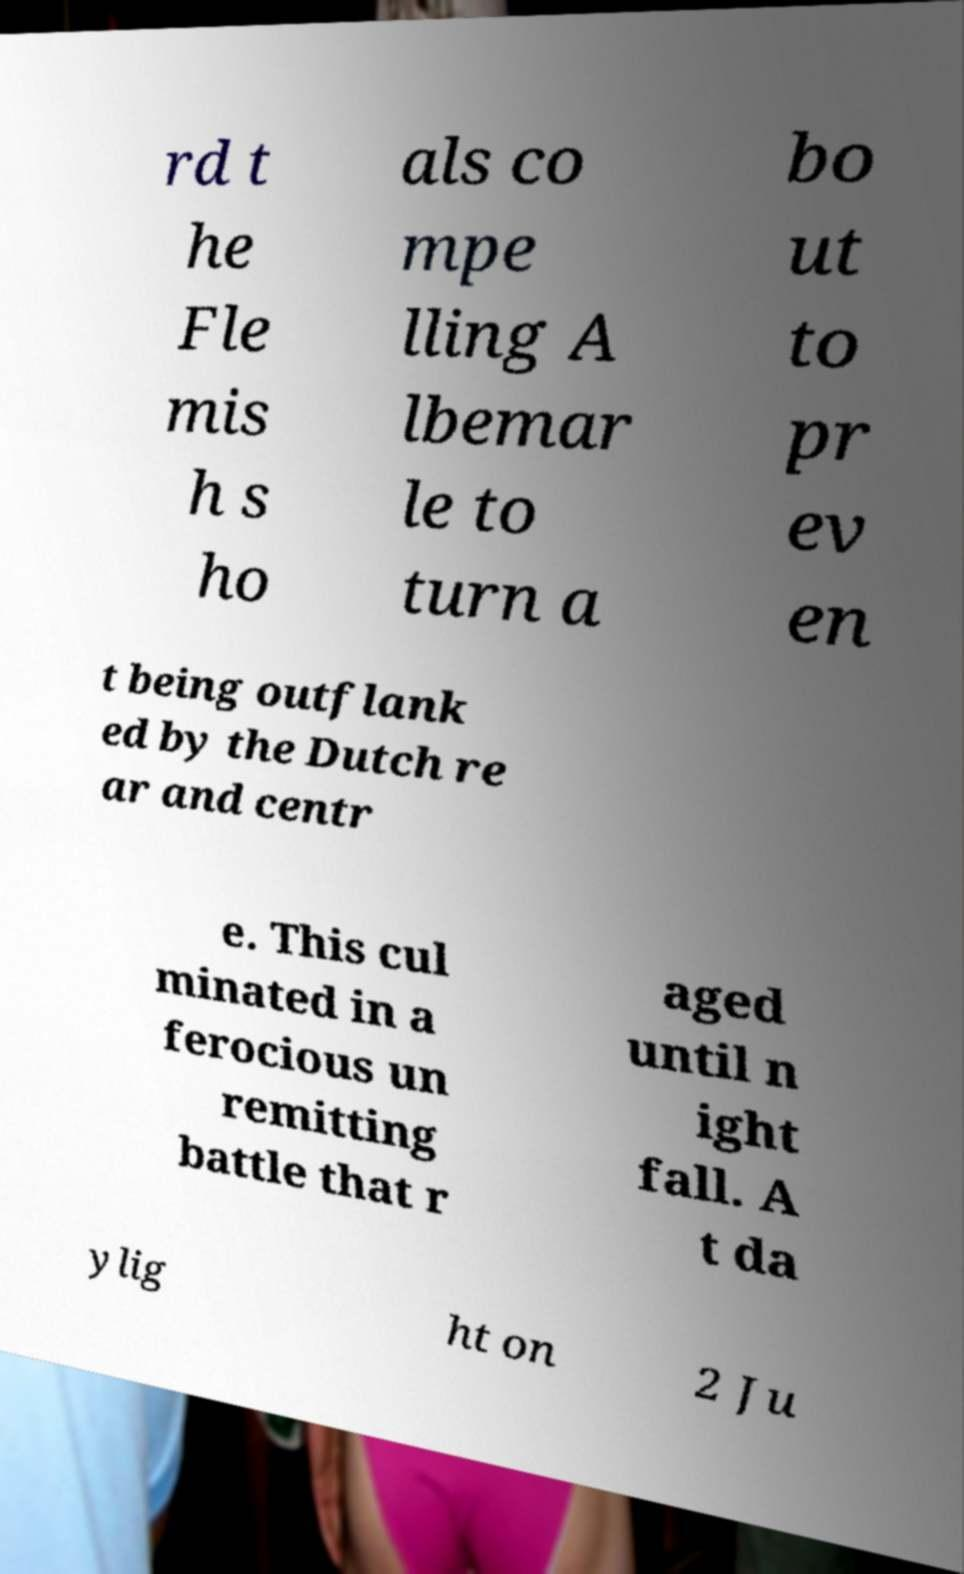Please read and relay the text visible in this image. What does it say? rd t he Fle mis h s ho als co mpe lling A lbemar le to turn a bo ut to pr ev en t being outflank ed by the Dutch re ar and centr e. This cul minated in a ferocious un remitting battle that r aged until n ight fall. A t da ylig ht on 2 Ju 